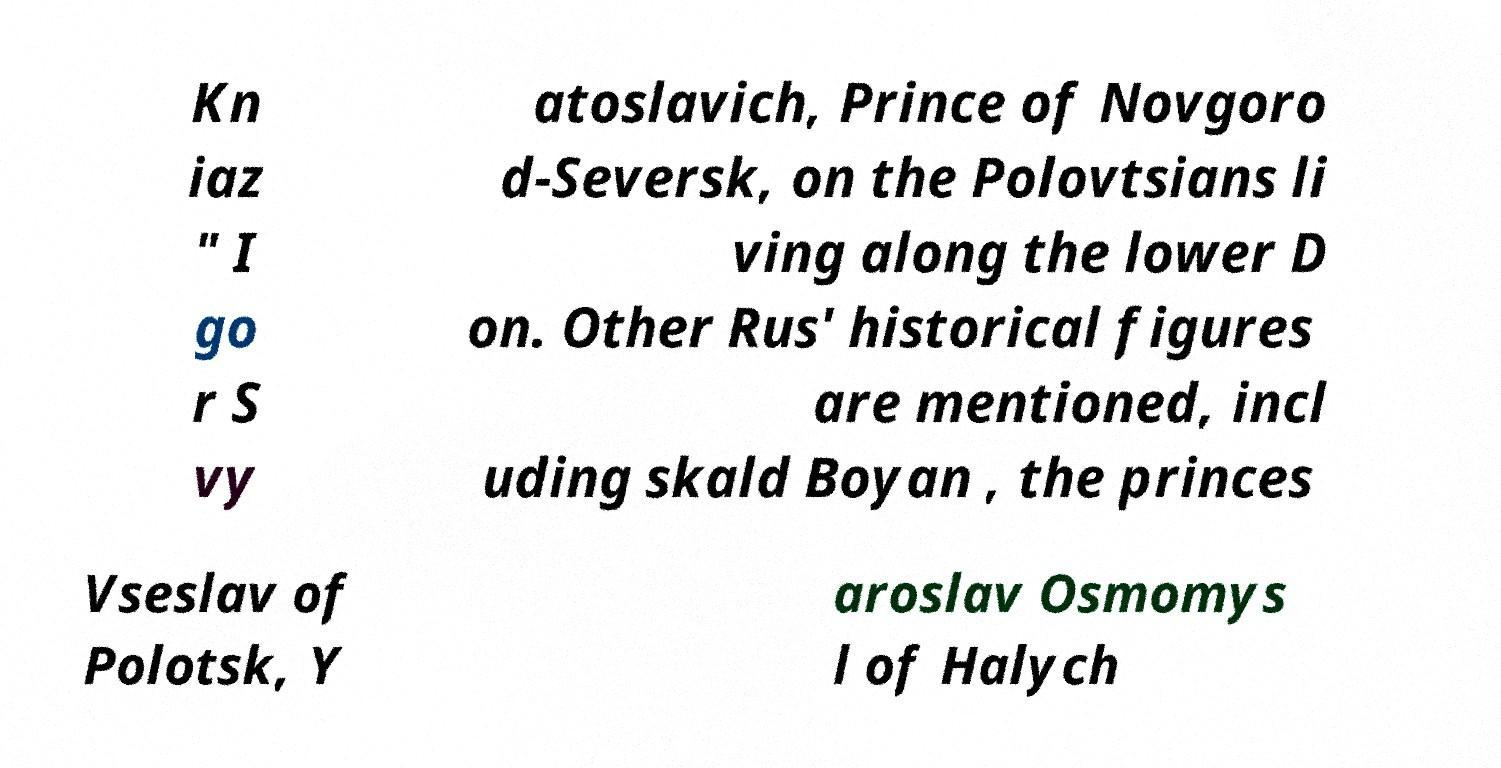For documentation purposes, I need the text within this image transcribed. Could you provide that? Kn iaz " I go r S vy atoslavich, Prince of Novgoro d-Seversk, on the Polovtsians li ving along the lower D on. Other Rus' historical figures are mentioned, incl uding skald Boyan , the princes Vseslav of Polotsk, Y aroslav Osmomys l of Halych 